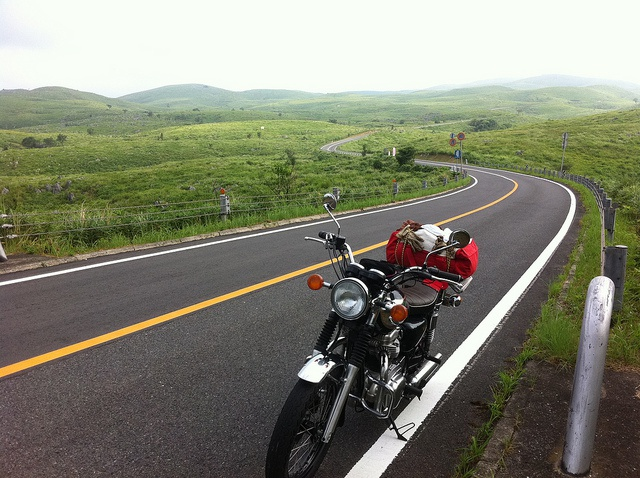Describe the objects in this image and their specific colors. I can see a motorcycle in white, black, gray, and darkgray tones in this image. 